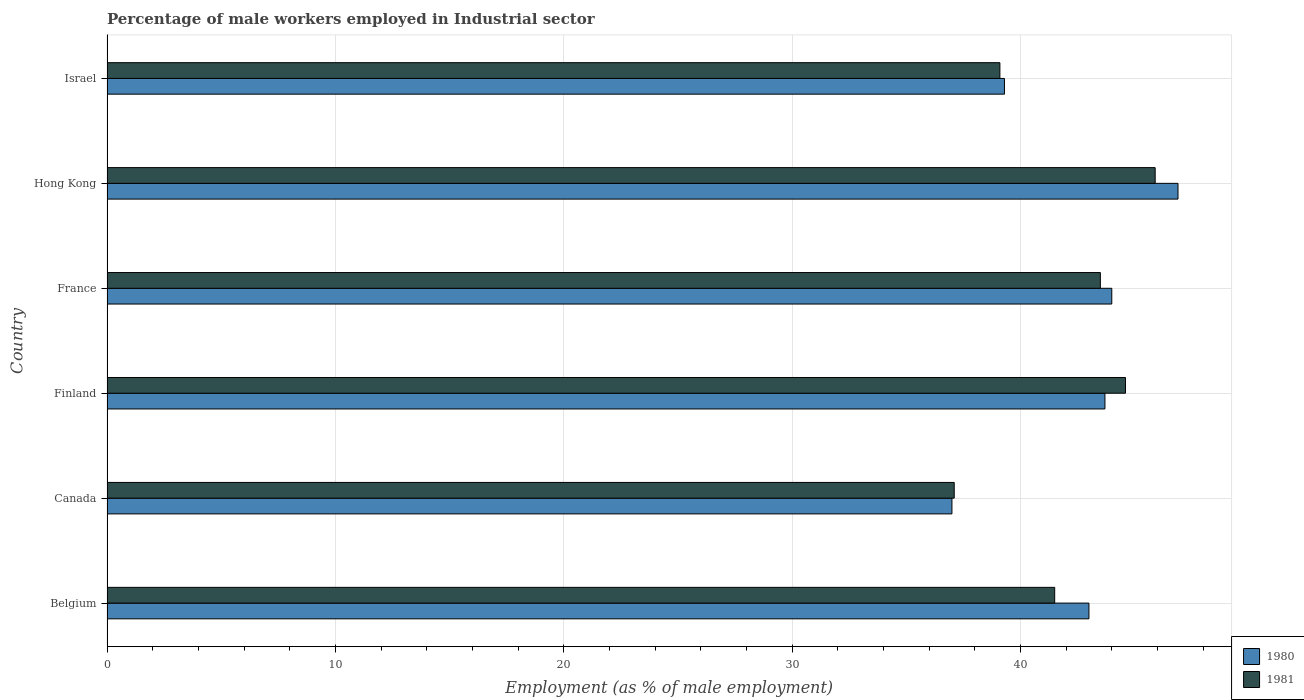Are the number of bars per tick equal to the number of legend labels?
Keep it short and to the point. Yes. How many bars are there on the 6th tick from the bottom?
Make the answer very short. 2. What is the percentage of male workers employed in Industrial sector in 1981 in Hong Kong?
Keep it short and to the point. 45.9. Across all countries, what is the maximum percentage of male workers employed in Industrial sector in 1981?
Offer a terse response. 45.9. In which country was the percentage of male workers employed in Industrial sector in 1981 maximum?
Make the answer very short. Hong Kong. What is the total percentage of male workers employed in Industrial sector in 1981 in the graph?
Offer a very short reply. 251.7. What is the difference between the percentage of male workers employed in Industrial sector in 1981 in Belgium and that in Hong Kong?
Provide a short and direct response. -4.4. What is the difference between the percentage of male workers employed in Industrial sector in 1980 in Hong Kong and the percentage of male workers employed in Industrial sector in 1981 in France?
Offer a terse response. 3.4. What is the average percentage of male workers employed in Industrial sector in 1981 per country?
Provide a succinct answer. 41.95. What is the ratio of the percentage of male workers employed in Industrial sector in 1981 in Canada to that in Finland?
Provide a succinct answer. 0.83. Is the difference between the percentage of male workers employed in Industrial sector in 1981 in Hong Kong and Israel greater than the difference between the percentage of male workers employed in Industrial sector in 1980 in Hong Kong and Israel?
Your answer should be compact. No. What is the difference between the highest and the second highest percentage of male workers employed in Industrial sector in 1981?
Offer a very short reply. 1.3. What is the difference between the highest and the lowest percentage of male workers employed in Industrial sector in 1980?
Provide a short and direct response. 9.9. Is the sum of the percentage of male workers employed in Industrial sector in 1981 in Finland and France greater than the maximum percentage of male workers employed in Industrial sector in 1980 across all countries?
Provide a succinct answer. Yes. How many bars are there?
Offer a very short reply. 12. Are all the bars in the graph horizontal?
Your answer should be compact. Yes. How many countries are there in the graph?
Ensure brevity in your answer.  6. What is the difference between two consecutive major ticks on the X-axis?
Your answer should be compact. 10. Does the graph contain any zero values?
Offer a terse response. No. How are the legend labels stacked?
Offer a terse response. Vertical. What is the title of the graph?
Your answer should be compact. Percentage of male workers employed in Industrial sector. Does "1965" appear as one of the legend labels in the graph?
Offer a very short reply. No. What is the label or title of the X-axis?
Your response must be concise. Employment (as % of male employment). What is the label or title of the Y-axis?
Provide a succinct answer. Country. What is the Employment (as % of male employment) of 1981 in Belgium?
Provide a short and direct response. 41.5. What is the Employment (as % of male employment) of 1981 in Canada?
Your response must be concise. 37.1. What is the Employment (as % of male employment) in 1980 in Finland?
Give a very brief answer. 43.7. What is the Employment (as % of male employment) in 1981 in Finland?
Provide a succinct answer. 44.6. What is the Employment (as % of male employment) in 1981 in France?
Your response must be concise. 43.5. What is the Employment (as % of male employment) in 1980 in Hong Kong?
Your response must be concise. 46.9. What is the Employment (as % of male employment) in 1981 in Hong Kong?
Ensure brevity in your answer.  45.9. What is the Employment (as % of male employment) in 1980 in Israel?
Give a very brief answer. 39.3. What is the Employment (as % of male employment) in 1981 in Israel?
Your answer should be very brief. 39.1. Across all countries, what is the maximum Employment (as % of male employment) in 1980?
Your answer should be compact. 46.9. Across all countries, what is the maximum Employment (as % of male employment) in 1981?
Your response must be concise. 45.9. Across all countries, what is the minimum Employment (as % of male employment) of 1980?
Provide a short and direct response. 37. Across all countries, what is the minimum Employment (as % of male employment) of 1981?
Offer a very short reply. 37.1. What is the total Employment (as % of male employment) of 1980 in the graph?
Offer a terse response. 253.9. What is the total Employment (as % of male employment) of 1981 in the graph?
Give a very brief answer. 251.7. What is the difference between the Employment (as % of male employment) in 1980 in Belgium and that in Finland?
Provide a short and direct response. -0.7. What is the difference between the Employment (as % of male employment) in 1981 in Belgium and that in Israel?
Offer a terse response. 2.4. What is the difference between the Employment (as % of male employment) in 1981 in Canada and that in Finland?
Keep it short and to the point. -7.5. What is the difference between the Employment (as % of male employment) in 1980 in Canada and that in France?
Your response must be concise. -7. What is the difference between the Employment (as % of male employment) in 1981 in Canada and that in France?
Your answer should be very brief. -6.4. What is the difference between the Employment (as % of male employment) in 1980 in Canada and that in Hong Kong?
Keep it short and to the point. -9.9. What is the difference between the Employment (as % of male employment) in 1981 in Canada and that in Hong Kong?
Offer a terse response. -8.8. What is the difference between the Employment (as % of male employment) in 1980 in Canada and that in Israel?
Provide a succinct answer. -2.3. What is the difference between the Employment (as % of male employment) of 1981 in Finland and that in France?
Offer a terse response. 1.1. What is the difference between the Employment (as % of male employment) in 1981 in Finland and that in Israel?
Your response must be concise. 5.5. What is the difference between the Employment (as % of male employment) in 1980 in France and that in Hong Kong?
Your response must be concise. -2.9. What is the difference between the Employment (as % of male employment) in 1980 in France and that in Israel?
Offer a terse response. 4.7. What is the difference between the Employment (as % of male employment) of 1981 in France and that in Israel?
Ensure brevity in your answer.  4.4. What is the difference between the Employment (as % of male employment) in 1980 in Hong Kong and that in Israel?
Give a very brief answer. 7.6. What is the difference between the Employment (as % of male employment) of 1981 in Hong Kong and that in Israel?
Keep it short and to the point. 6.8. What is the difference between the Employment (as % of male employment) in 1980 in Belgium and the Employment (as % of male employment) in 1981 in Canada?
Offer a terse response. 5.9. What is the difference between the Employment (as % of male employment) in 1980 in Belgium and the Employment (as % of male employment) in 1981 in Finland?
Offer a very short reply. -1.6. What is the difference between the Employment (as % of male employment) in 1980 in Belgium and the Employment (as % of male employment) in 1981 in France?
Ensure brevity in your answer.  -0.5. What is the difference between the Employment (as % of male employment) of 1980 in Canada and the Employment (as % of male employment) of 1981 in Hong Kong?
Your response must be concise. -8.9. What is the difference between the Employment (as % of male employment) in 1980 in Canada and the Employment (as % of male employment) in 1981 in Israel?
Provide a succinct answer. -2.1. What is the difference between the Employment (as % of male employment) of 1980 in Finland and the Employment (as % of male employment) of 1981 in Hong Kong?
Your response must be concise. -2.2. What is the difference between the Employment (as % of male employment) of 1980 in Finland and the Employment (as % of male employment) of 1981 in Israel?
Keep it short and to the point. 4.6. What is the difference between the Employment (as % of male employment) in 1980 in Hong Kong and the Employment (as % of male employment) in 1981 in Israel?
Give a very brief answer. 7.8. What is the average Employment (as % of male employment) in 1980 per country?
Offer a terse response. 42.32. What is the average Employment (as % of male employment) of 1981 per country?
Keep it short and to the point. 41.95. What is the difference between the Employment (as % of male employment) in 1980 and Employment (as % of male employment) in 1981 in Belgium?
Provide a short and direct response. 1.5. What is the difference between the Employment (as % of male employment) of 1980 and Employment (as % of male employment) of 1981 in Canada?
Make the answer very short. -0.1. What is the difference between the Employment (as % of male employment) in 1980 and Employment (as % of male employment) in 1981 in Finland?
Keep it short and to the point. -0.9. What is the ratio of the Employment (as % of male employment) in 1980 in Belgium to that in Canada?
Give a very brief answer. 1.16. What is the ratio of the Employment (as % of male employment) in 1981 in Belgium to that in Canada?
Provide a succinct answer. 1.12. What is the ratio of the Employment (as % of male employment) of 1981 in Belgium to that in Finland?
Your answer should be very brief. 0.93. What is the ratio of the Employment (as % of male employment) of 1980 in Belgium to that in France?
Ensure brevity in your answer.  0.98. What is the ratio of the Employment (as % of male employment) in 1981 in Belgium to that in France?
Your answer should be very brief. 0.95. What is the ratio of the Employment (as % of male employment) of 1980 in Belgium to that in Hong Kong?
Your response must be concise. 0.92. What is the ratio of the Employment (as % of male employment) of 1981 in Belgium to that in Hong Kong?
Your answer should be compact. 0.9. What is the ratio of the Employment (as % of male employment) in 1980 in Belgium to that in Israel?
Your response must be concise. 1.09. What is the ratio of the Employment (as % of male employment) in 1981 in Belgium to that in Israel?
Provide a succinct answer. 1.06. What is the ratio of the Employment (as % of male employment) of 1980 in Canada to that in Finland?
Your answer should be very brief. 0.85. What is the ratio of the Employment (as % of male employment) of 1981 in Canada to that in Finland?
Offer a very short reply. 0.83. What is the ratio of the Employment (as % of male employment) of 1980 in Canada to that in France?
Make the answer very short. 0.84. What is the ratio of the Employment (as % of male employment) of 1981 in Canada to that in France?
Your response must be concise. 0.85. What is the ratio of the Employment (as % of male employment) in 1980 in Canada to that in Hong Kong?
Make the answer very short. 0.79. What is the ratio of the Employment (as % of male employment) of 1981 in Canada to that in Hong Kong?
Provide a succinct answer. 0.81. What is the ratio of the Employment (as % of male employment) of 1980 in Canada to that in Israel?
Your response must be concise. 0.94. What is the ratio of the Employment (as % of male employment) in 1981 in Canada to that in Israel?
Offer a very short reply. 0.95. What is the ratio of the Employment (as % of male employment) of 1980 in Finland to that in France?
Your response must be concise. 0.99. What is the ratio of the Employment (as % of male employment) of 1981 in Finland to that in France?
Give a very brief answer. 1.03. What is the ratio of the Employment (as % of male employment) of 1980 in Finland to that in Hong Kong?
Give a very brief answer. 0.93. What is the ratio of the Employment (as % of male employment) in 1981 in Finland to that in Hong Kong?
Make the answer very short. 0.97. What is the ratio of the Employment (as % of male employment) of 1980 in Finland to that in Israel?
Keep it short and to the point. 1.11. What is the ratio of the Employment (as % of male employment) of 1981 in Finland to that in Israel?
Keep it short and to the point. 1.14. What is the ratio of the Employment (as % of male employment) in 1980 in France to that in Hong Kong?
Ensure brevity in your answer.  0.94. What is the ratio of the Employment (as % of male employment) in 1981 in France to that in Hong Kong?
Provide a short and direct response. 0.95. What is the ratio of the Employment (as % of male employment) in 1980 in France to that in Israel?
Provide a succinct answer. 1.12. What is the ratio of the Employment (as % of male employment) in 1981 in France to that in Israel?
Provide a succinct answer. 1.11. What is the ratio of the Employment (as % of male employment) in 1980 in Hong Kong to that in Israel?
Give a very brief answer. 1.19. What is the ratio of the Employment (as % of male employment) of 1981 in Hong Kong to that in Israel?
Make the answer very short. 1.17. What is the difference between the highest and the second highest Employment (as % of male employment) of 1980?
Offer a terse response. 2.9. What is the difference between the highest and the lowest Employment (as % of male employment) of 1980?
Your answer should be compact. 9.9. 